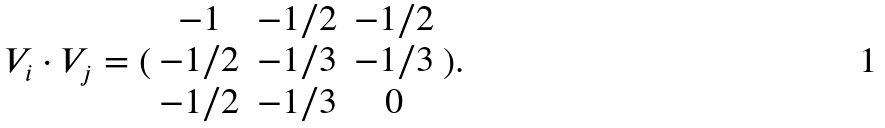<formula> <loc_0><loc_0><loc_500><loc_500>V _ { i } \cdot V _ { j } = ( \begin{array} { c c c } - 1 & - 1 / 2 & - 1 / 2 \\ - 1 / 2 & - 1 / 3 & - 1 / 3 \\ - 1 / 2 & - 1 / 3 & 0 \end{array} ) .</formula> 